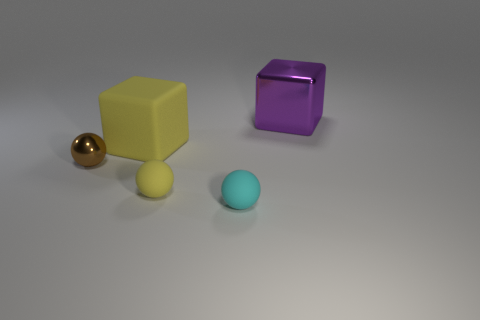How many blocks are large shiny objects or big things? In the image, there are two objects that can be considered as 'large shiny blocks' or 'big things': a large, shiny yellow cube and a larger, shiny purple block with a reflective surface. 